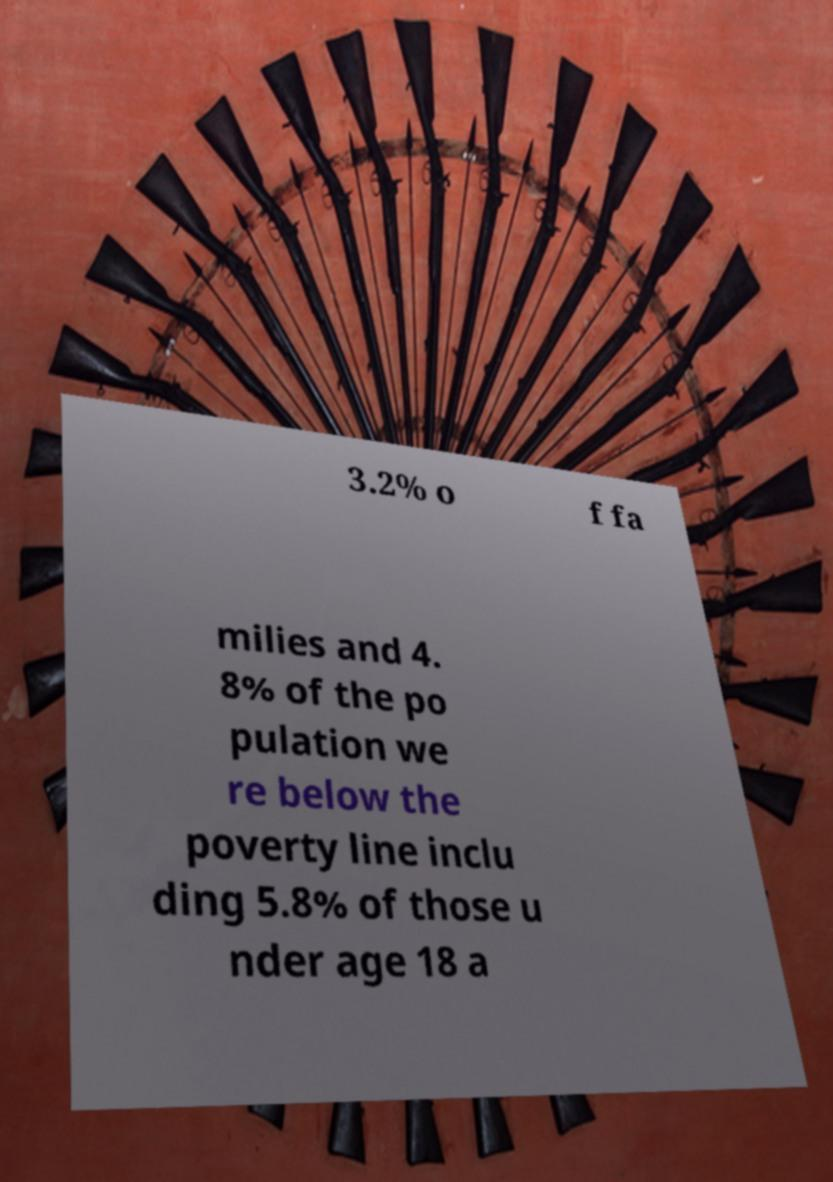Can you read and provide the text displayed in the image?This photo seems to have some interesting text. Can you extract and type it out for me? 3.2% o f fa milies and 4. 8% of the po pulation we re below the poverty line inclu ding 5.8% of those u nder age 18 a 